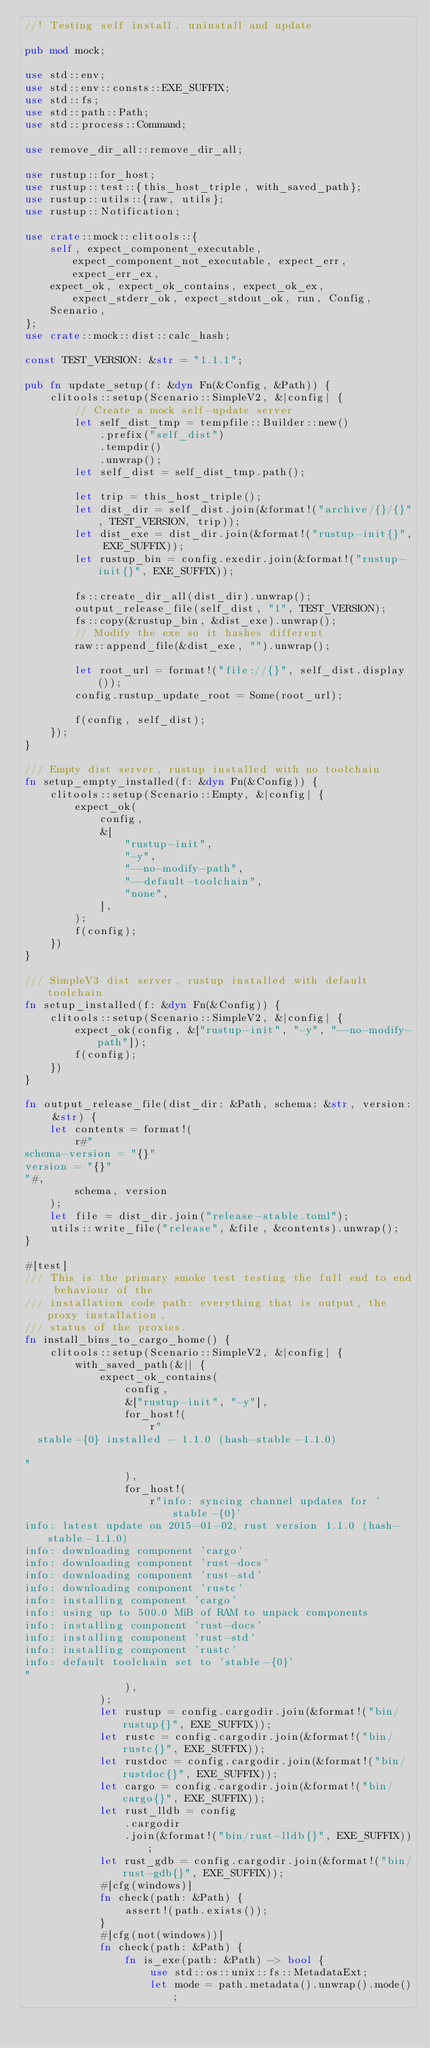<code> <loc_0><loc_0><loc_500><loc_500><_Rust_>//! Testing self install, uninstall and update

pub mod mock;

use std::env;
use std::env::consts::EXE_SUFFIX;
use std::fs;
use std::path::Path;
use std::process::Command;

use remove_dir_all::remove_dir_all;

use rustup::for_host;
use rustup::test::{this_host_triple, with_saved_path};
use rustup::utils::{raw, utils};
use rustup::Notification;

use crate::mock::clitools::{
    self, expect_component_executable, expect_component_not_executable, expect_err, expect_err_ex,
    expect_ok, expect_ok_contains, expect_ok_ex, expect_stderr_ok, expect_stdout_ok, run, Config,
    Scenario,
};
use crate::mock::dist::calc_hash;

const TEST_VERSION: &str = "1.1.1";

pub fn update_setup(f: &dyn Fn(&Config, &Path)) {
    clitools::setup(Scenario::SimpleV2, &|config| {
        // Create a mock self-update server
        let self_dist_tmp = tempfile::Builder::new()
            .prefix("self_dist")
            .tempdir()
            .unwrap();
        let self_dist = self_dist_tmp.path();

        let trip = this_host_triple();
        let dist_dir = self_dist.join(&format!("archive/{}/{}", TEST_VERSION, trip));
        let dist_exe = dist_dir.join(&format!("rustup-init{}", EXE_SUFFIX));
        let rustup_bin = config.exedir.join(&format!("rustup-init{}", EXE_SUFFIX));

        fs::create_dir_all(dist_dir).unwrap();
        output_release_file(self_dist, "1", TEST_VERSION);
        fs::copy(&rustup_bin, &dist_exe).unwrap();
        // Modify the exe so it hashes different
        raw::append_file(&dist_exe, "").unwrap();

        let root_url = format!("file://{}", self_dist.display());
        config.rustup_update_root = Some(root_url);

        f(config, self_dist);
    });
}

/// Empty dist server, rustup installed with no toolchain
fn setup_empty_installed(f: &dyn Fn(&Config)) {
    clitools::setup(Scenario::Empty, &|config| {
        expect_ok(
            config,
            &[
                "rustup-init",
                "-y",
                "--no-modify-path",
                "--default-toolchain",
                "none",
            ],
        );
        f(config);
    })
}

/// SimpleV3 dist server, rustup installed with default toolchain
fn setup_installed(f: &dyn Fn(&Config)) {
    clitools::setup(Scenario::SimpleV2, &|config| {
        expect_ok(config, &["rustup-init", "-y", "--no-modify-path"]);
        f(config);
    })
}

fn output_release_file(dist_dir: &Path, schema: &str, version: &str) {
    let contents = format!(
        r#"
schema-version = "{}"
version = "{}"
"#,
        schema, version
    );
    let file = dist_dir.join("release-stable.toml");
    utils::write_file("release", &file, &contents).unwrap();
}

#[test]
/// This is the primary smoke test testing the full end to end behaviour of the
/// installation code path: everything that is output, the proxy installation,
/// status of the proxies.
fn install_bins_to_cargo_home() {
    clitools::setup(Scenario::SimpleV2, &|config| {
        with_saved_path(&|| {
            expect_ok_contains(
                config,
                &["rustup-init", "-y"],
                for_host!(
                    r"
  stable-{0} installed - 1.1.0 (hash-stable-1.1.0)

"
                ),
                for_host!(
                    r"info: syncing channel updates for 'stable-{0}'
info: latest update on 2015-01-02, rust version 1.1.0 (hash-stable-1.1.0)
info: downloading component 'cargo'
info: downloading component 'rust-docs'
info: downloading component 'rust-std'
info: downloading component 'rustc'
info: installing component 'cargo'
info: using up to 500.0 MiB of RAM to unpack components
info: installing component 'rust-docs'
info: installing component 'rust-std'
info: installing component 'rustc'
info: default toolchain set to 'stable-{0}'
"
                ),
            );
            let rustup = config.cargodir.join(&format!("bin/rustup{}", EXE_SUFFIX));
            let rustc = config.cargodir.join(&format!("bin/rustc{}", EXE_SUFFIX));
            let rustdoc = config.cargodir.join(&format!("bin/rustdoc{}", EXE_SUFFIX));
            let cargo = config.cargodir.join(&format!("bin/cargo{}", EXE_SUFFIX));
            let rust_lldb = config
                .cargodir
                .join(&format!("bin/rust-lldb{}", EXE_SUFFIX));
            let rust_gdb = config.cargodir.join(&format!("bin/rust-gdb{}", EXE_SUFFIX));
            #[cfg(windows)]
            fn check(path: &Path) {
                assert!(path.exists());
            }
            #[cfg(not(windows))]
            fn check(path: &Path) {
                fn is_exe(path: &Path) -> bool {
                    use std::os::unix::fs::MetadataExt;
                    let mode = path.metadata().unwrap().mode();</code> 